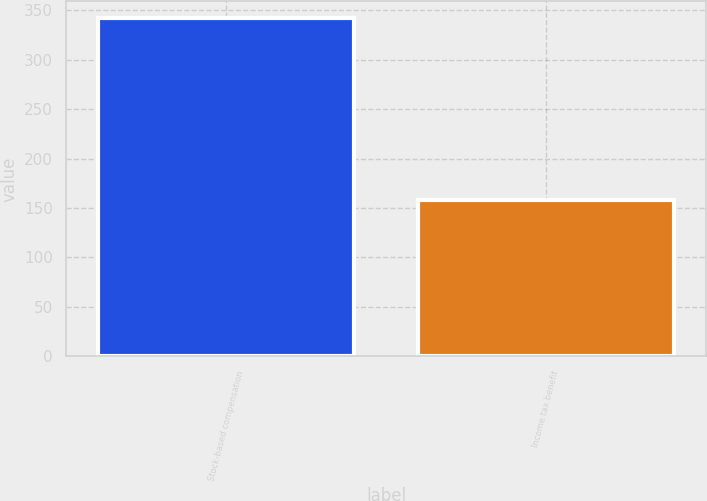<chart> <loc_0><loc_0><loc_500><loc_500><bar_chart><fcel>Stock-based compensation<fcel>Income tax benefit<nl><fcel>342<fcel>158<nl></chart> 